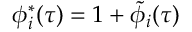Convert formula to latex. <formula><loc_0><loc_0><loc_500><loc_500>\phi _ { i } ^ { * } ( \tau ) = 1 + \tilde { \phi } _ { i } ( \tau )</formula> 